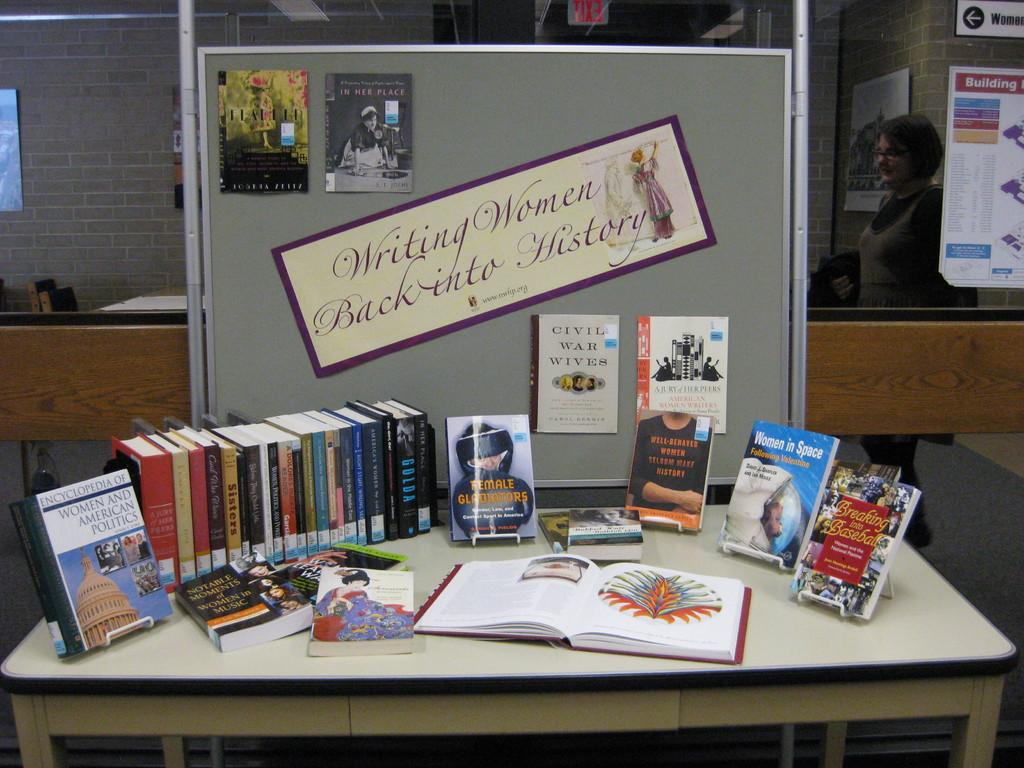<image>
Share a concise interpretation of the image provided. Some books are on a display while at the back there is a banner about writing women back into history. 